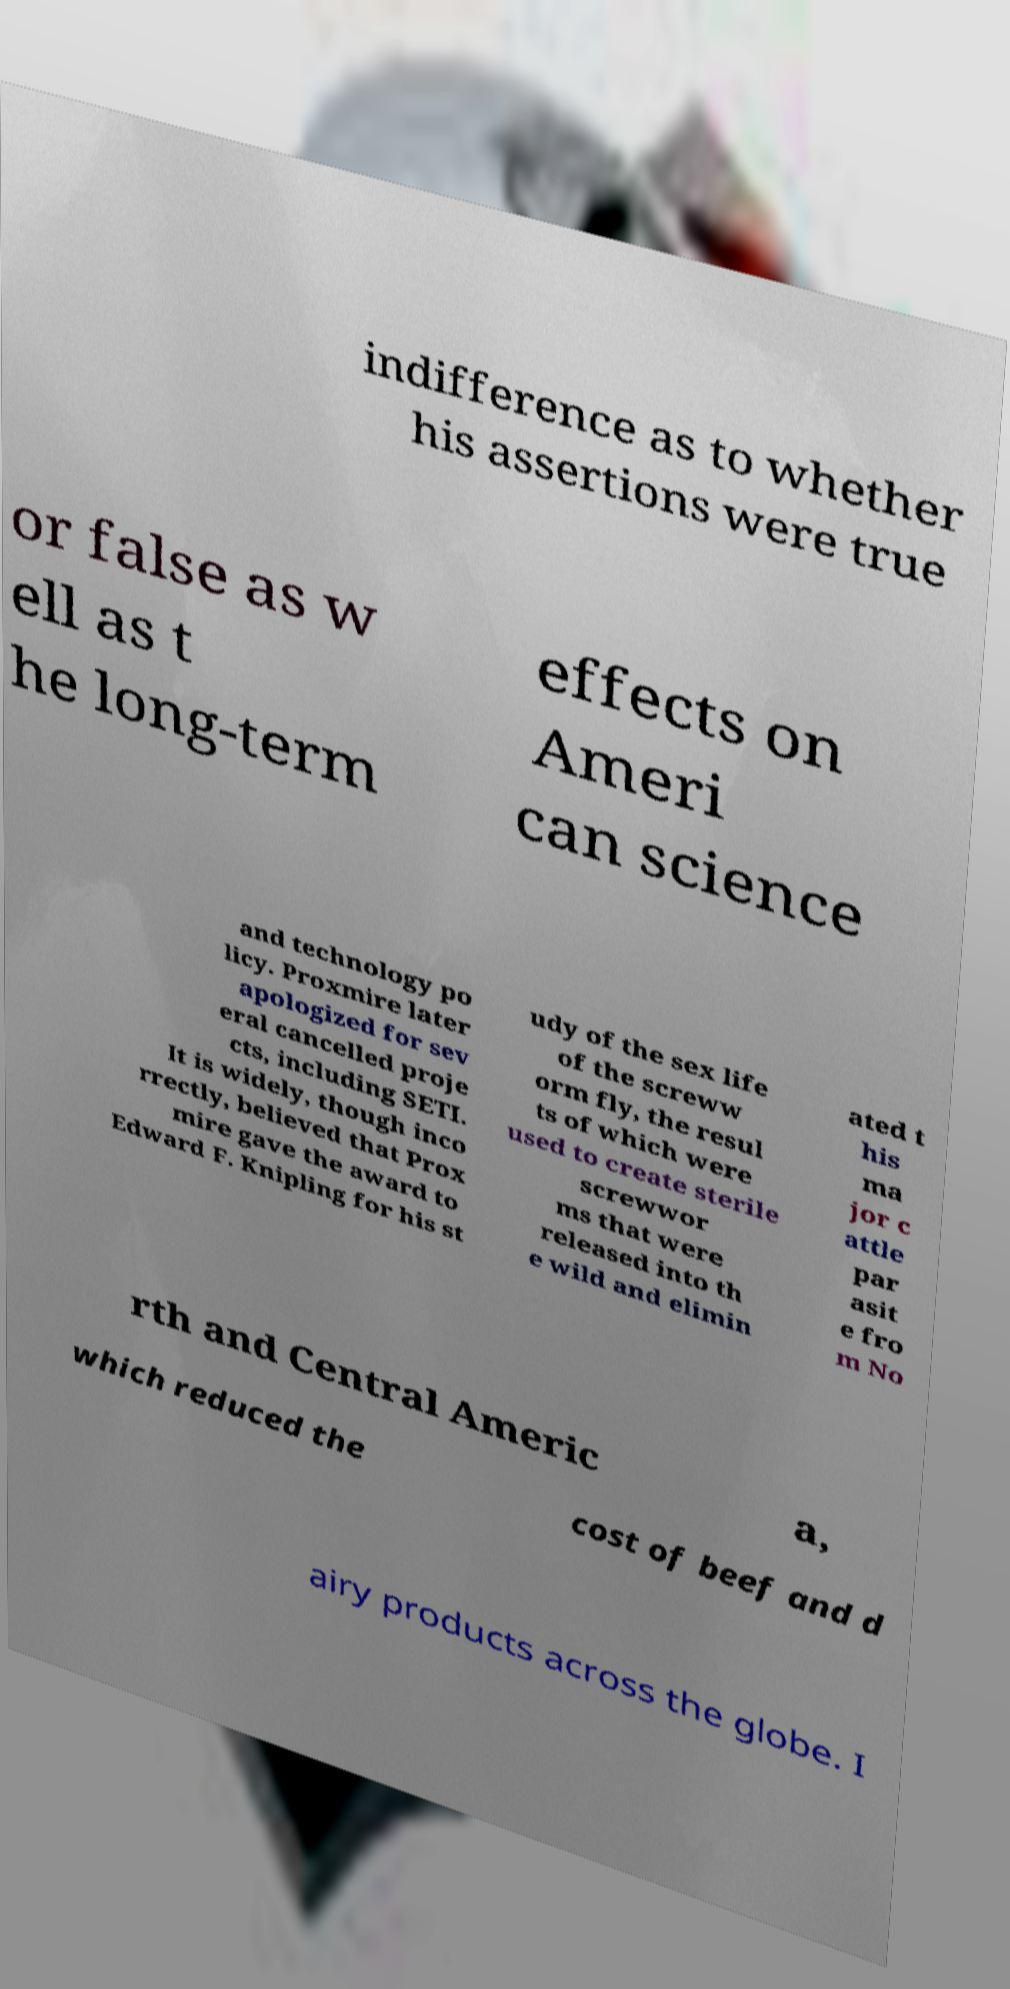Could you assist in decoding the text presented in this image and type it out clearly? indifference as to whether his assertions were true or false as w ell as t he long-term effects on Ameri can science and technology po licy. Proxmire later apologized for sev eral cancelled proje cts, including SETI. It is widely, though inco rrectly, believed that Prox mire gave the award to Edward F. Knipling for his st udy of the sex life of the screww orm fly, the resul ts of which were used to create sterile screwwor ms that were released into th e wild and elimin ated t his ma jor c attle par asit e fro m No rth and Central Americ a, which reduced the cost of beef and d airy products across the globe. I 